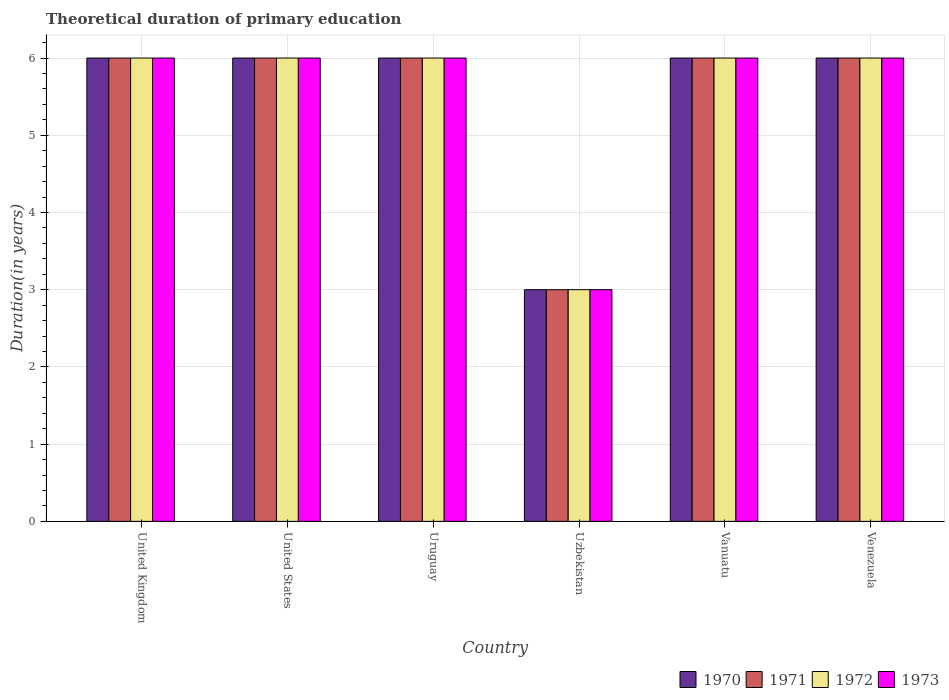Are the number of bars per tick equal to the number of legend labels?
Ensure brevity in your answer.  Yes. Are the number of bars on each tick of the X-axis equal?
Make the answer very short. Yes. How many bars are there on the 3rd tick from the right?
Your answer should be compact. 4. What is the label of the 2nd group of bars from the left?
Your answer should be compact. United States. What is the total theoretical duration of primary education in 1973 in Uzbekistan?
Offer a terse response. 3. Across all countries, what is the minimum total theoretical duration of primary education in 1970?
Give a very brief answer. 3. In which country was the total theoretical duration of primary education in 1970 maximum?
Your answer should be compact. United Kingdom. In which country was the total theoretical duration of primary education in 1972 minimum?
Ensure brevity in your answer.  Uzbekistan. What is the difference between the total theoretical duration of primary education in 1973 in United States and that in Vanuatu?
Provide a succinct answer. 0. In how many countries, is the total theoretical duration of primary education in 1970 greater than 5.4 years?
Ensure brevity in your answer.  5. Is the total theoretical duration of primary education in 1971 in Uruguay less than that in Uzbekistan?
Provide a succinct answer. No. Is it the case that in every country, the sum of the total theoretical duration of primary education in 1972 and total theoretical duration of primary education in 1971 is greater than the total theoretical duration of primary education in 1970?
Keep it short and to the point. Yes. How many countries are there in the graph?
Your answer should be very brief. 6. What is the difference between two consecutive major ticks on the Y-axis?
Your answer should be very brief. 1. Does the graph contain any zero values?
Ensure brevity in your answer.  No. Does the graph contain grids?
Provide a short and direct response. Yes. Where does the legend appear in the graph?
Offer a terse response. Bottom right. What is the title of the graph?
Provide a short and direct response. Theoretical duration of primary education. What is the label or title of the X-axis?
Your answer should be compact. Country. What is the label or title of the Y-axis?
Your answer should be very brief. Duration(in years). What is the Duration(in years) in 1971 in United Kingdom?
Provide a short and direct response. 6. What is the Duration(in years) of 1972 in United Kingdom?
Provide a short and direct response. 6. What is the Duration(in years) of 1973 in United Kingdom?
Keep it short and to the point. 6. What is the Duration(in years) in 1971 in United States?
Your answer should be very brief. 6. What is the Duration(in years) of 1972 in United States?
Keep it short and to the point. 6. What is the Duration(in years) in 1973 in United States?
Provide a succinct answer. 6. What is the Duration(in years) of 1970 in Uruguay?
Make the answer very short. 6. What is the Duration(in years) in 1972 in Uruguay?
Make the answer very short. 6. What is the Duration(in years) of 1973 in Uruguay?
Make the answer very short. 6. What is the Duration(in years) of 1972 in Uzbekistan?
Your answer should be very brief. 3. What is the Duration(in years) in 1973 in Uzbekistan?
Offer a terse response. 3. What is the Duration(in years) of 1973 in Vanuatu?
Give a very brief answer. 6. What is the Duration(in years) of 1971 in Venezuela?
Provide a short and direct response. 6. What is the Duration(in years) in 1972 in Venezuela?
Keep it short and to the point. 6. Across all countries, what is the maximum Duration(in years) of 1971?
Your answer should be compact. 6. Across all countries, what is the maximum Duration(in years) in 1972?
Your answer should be very brief. 6. Across all countries, what is the maximum Duration(in years) of 1973?
Provide a succinct answer. 6. Across all countries, what is the minimum Duration(in years) in 1970?
Make the answer very short. 3. Across all countries, what is the minimum Duration(in years) in 1972?
Make the answer very short. 3. What is the total Duration(in years) in 1971 in the graph?
Provide a short and direct response. 33. What is the total Duration(in years) in 1973 in the graph?
Provide a succinct answer. 33. What is the difference between the Duration(in years) in 1970 in United Kingdom and that in Uruguay?
Provide a short and direct response. 0. What is the difference between the Duration(in years) of 1972 in United Kingdom and that in Uruguay?
Ensure brevity in your answer.  0. What is the difference between the Duration(in years) of 1973 in United Kingdom and that in Uruguay?
Your answer should be very brief. 0. What is the difference between the Duration(in years) of 1970 in United Kingdom and that in Uzbekistan?
Make the answer very short. 3. What is the difference between the Duration(in years) of 1971 in United Kingdom and that in Uzbekistan?
Make the answer very short. 3. What is the difference between the Duration(in years) in 1972 in United Kingdom and that in Uzbekistan?
Keep it short and to the point. 3. What is the difference between the Duration(in years) of 1973 in United Kingdom and that in Uzbekistan?
Give a very brief answer. 3. What is the difference between the Duration(in years) of 1970 in United Kingdom and that in Vanuatu?
Your answer should be compact. 0. What is the difference between the Duration(in years) in 1972 in United Kingdom and that in Vanuatu?
Provide a short and direct response. 0. What is the difference between the Duration(in years) in 1973 in United Kingdom and that in Vanuatu?
Ensure brevity in your answer.  0. What is the difference between the Duration(in years) in 1970 in United Kingdom and that in Venezuela?
Your answer should be compact. 0. What is the difference between the Duration(in years) in 1971 in United Kingdom and that in Venezuela?
Give a very brief answer. 0. What is the difference between the Duration(in years) in 1972 in United Kingdom and that in Venezuela?
Your response must be concise. 0. What is the difference between the Duration(in years) in 1973 in United Kingdom and that in Venezuela?
Your answer should be compact. 0. What is the difference between the Duration(in years) of 1971 in United States and that in Uruguay?
Your response must be concise. 0. What is the difference between the Duration(in years) of 1972 in United States and that in Uzbekistan?
Offer a terse response. 3. What is the difference between the Duration(in years) of 1972 in United States and that in Vanuatu?
Your response must be concise. 0. What is the difference between the Duration(in years) in 1970 in United States and that in Venezuela?
Provide a succinct answer. 0. What is the difference between the Duration(in years) of 1970 in Uruguay and that in Uzbekistan?
Provide a succinct answer. 3. What is the difference between the Duration(in years) in 1972 in Uruguay and that in Uzbekistan?
Your answer should be compact. 3. What is the difference between the Duration(in years) in 1971 in Uruguay and that in Vanuatu?
Offer a very short reply. 0. What is the difference between the Duration(in years) of 1970 in Uzbekistan and that in Vanuatu?
Your answer should be very brief. -3. What is the difference between the Duration(in years) of 1973 in Uzbekistan and that in Vanuatu?
Offer a terse response. -3. What is the difference between the Duration(in years) in 1970 in Uzbekistan and that in Venezuela?
Give a very brief answer. -3. What is the difference between the Duration(in years) in 1971 in Uzbekistan and that in Venezuela?
Give a very brief answer. -3. What is the difference between the Duration(in years) of 1972 in Uzbekistan and that in Venezuela?
Keep it short and to the point. -3. What is the difference between the Duration(in years) in 1970 in Vanuatu and that in Venezuela?
Offer a terse response. 0. What is the difference between the Duration(in years) of 1971 in Vanuatu and that in Venezuela?
Your answer should be very brief. 0. What is the difference between the Duration(in years) of 1970 in United Kingdom and the Duration(in years) of 1971 in United States?
Provide a short and direct response. 0. What is the difference between the Duration(in years) in 1970 in United Kingdom and the Duration(in years) in 1973 in United States?
Offer a very short reply. 0. What is the difference between the Duration(in years) in 1971 in United Kingdom and the Duration(in years) in 1973 in United States?
Your answer should be compact. 0. What is the difference between the Duration(in years) of 1970 in United Kingdom and the Duration(in years) of 1971 in Uruguay?
Offer a terse response. 0. What is the difference between the Duration(in years) in 1971 in United Kingdom and the Duration(in years) in 1973 in Uruguay?
Give a very brief answer. 0. What is the difference between the Duration(in years) in 1970 in United Kingdom and the Duration(in years) in 1971 in Uzbekistan?
Provide a short and direct response. 3. What is the difference between the Duration(in years) of 1971 in United Kingdom and the Duration(in years) of 1972 in Uzbekistan?
Keep it short and to the point. 3. What is the difference between the Duration(in years) of 1970 in United Kingdom and the Duration(in years) of 1972 in Venezuela?
Offer a terse response. 0. What is the difference between the Duration(in years) in 1970 in United Kingdom and the Duration(in years) in 1973 in Venezuela?
Your answer should be very brief. 0. What is the difference between the Duration(in years) of 1971 in United Kingdom and the Duration(in years) of 1972 in Venezuela?
Offer a terse response. 0. What is the difference between the Duration(in years) in 1971 in United Kingdom and the Duration(in years) in 1973 in Venezuela?
Give a very brief answer. 0. What is the difference between the Duration(in years) of 1970 in United States and the Duration(in years) of 1971 in Uruguay?
Your answer should be compact. 0. What is the difference between the Duration(in years) in 1971 in United States and the Duration(in years) in 1973 in Uruguay?
Offer a terse response. 0. What is the difference between the Duration(in years) of 1972 in United States and the Duration(in years) of 1973 in Uruguay?
Provide a succinct answer. 0. What is the difference between the Duration(in years) in 1970 in United States and the Duration(in years) in 1973 in Uzbekistan?
Offer a terse response. 3. What is the difference between the Duration(in years) in 1971 in United States and the Duration(in years) in 1973 in Uzbekistan?
Your answer should be very brief. 3. What is the difference between the Duration(in years) of 1972 in United States and the Duration(in years) of 1973 in Uzbekistan?
Offer a terse response. 3. What is the difference between the Duration(in years) in 1970 in United States and the Duration(in years) in 1971 in Vanuatu?
Your response must be concise. 0. What is the difference between the Duration(in years) in 1970 in United States and the Duration(in years) in 1973 in Vanuatu?
Make the answer very short. 0. What is the difference between the Duration(in years) in 1971 in United States and the Duration(in years) in 1972 in Vanuatu?
Your answer should be compact. 0. What is the difference between the Duration(in years) of 1972 in United States and the Duration(in years) of 1973 in Vanuatu?
Offer a very short reply. 0. What is the difference between the Duration(in years) of 1970 in United States and the Duration(in years) of 1972 in Venezuela?
Keep it short and to the point. 0. What is the difference between the Duration(in years) in 1970 in United States and the Duration(in years) in 1973 in Venezuela?
Your response must be concise. 0. What is the difference between the Duration(in years) of 1971 in United States and the Duration(in years) of 1972 in Venezuela?
Provide a short and direct response. 0. What is the difference between the Duration(in years) of 1971 in United States and the Duration(in years) of 1973 in Venezuela?
Keep it short and to the point. 0. What is the difference between the Duration(in years) in 1972 in United States and the Duration(in years) in 1973 in Venezuela?
Ensure brevity in your answer.  0. What is the difference between the Duration(in years) in 1970 in Uruguay and the Duration(in years) in 1971 in Uzbekistan?
Offer a terse response. 3. What is the difference between the Duration(in years) of 1970 in Uruguay and the Duration(in years) of 1972 in Uzbekistan?
Provide a succinct answer. 3. What is the difference between the Duration(in years) of 1970 in Uruguay and the Duration(in years) of 1973 in Uzbekistan?
Provide a succinct answer. 3. What is the difference between the Duration(in years) of 1971 in Uruguay and the Duration(in years) of 1973 in Uzbekistan?
Ensure brevity in your answer.  3. What is the difference between the Duration(in years) of 1972 in Uruguay and the Duration(in years) of 1973 in Uzbekistan?
Make the answer very short. 3. What is the difference between the Duration(in years) of 1972 in Uruguay and the Duration(in years) of 1973 in Vanuatu?
Keep it short and to the point. 0. What is the difference between the Duration(in years) in 1971 in Uruguay and the Duration(in years) in 1972 in Venezuela?
Give a very brief answer. 0. What is the difference between the Duration(in years) in 1972 in Uruguay and the Duration(in years) in 1973 in Venezuela?
Provide a short and direct response. 0. What is the difference between the Duration(in years) in 1970 in Uzbekistan and the Duration(in years) in 1971 in Vanuatu?
Make the answer very short. -3. What is the difference between the Duration(in years) of 1972 in Uzbekistan and the Duration(in years) of 1973 in Vanuatu?
Ensure brevity in your answer.  -3. What is the difference between the Duration(in years) in 1970 in Uzbekistan and the Duration(in years) in 1973 in Venezuela?
Provide a short and direct response. -3. What is the difference between the Duration(in years) in 1972 in Uzbekistan and the Duration(in years) in 1973 in Venezuela?
Your answer should be compact. -3. What is the difference between the Duration(in years) in 1970 in Vanuatu and the Duration(in years) in 1972 in Venezuela?
Offer a terse response. 0. What is the difference between the Duration(in years) in 1971 in Vanuatu and the Duration(in years) in 1973 in Venezuela?
Ensure brevity in your answer.  0. What is the difference between the Duration(in years) of 1972 in Vanuatu and the Duration(in years) of 1973 in Venezuela?
Provide a succinct answer. 0. What is the average Duration(in years) in 1972 per country?
Your answer should be very brief. 5.5. What is the difference between the Duration(in years) in 1970 and Duration(in years) in 1973 in United Kingdom?
Your response must be concise. 0. What is the difference between the Duration(in years) of 1970 and Duration(in years) of 1971 in United States?
Provide a short and direct response. 0. What is the difference between the Duration(in years) in 1971 and Duration(in years) in 1973 in United States?
Provide a succinct answer. 0. What is the difference between the Duration(in years) of 1970 and Duration(in years) of 1973 in Uruguay?
Offer a very short reply. 0. What is the difference between the Duration(in years) in 1970 and Duration(in years) in 1971 in Uzbekistan?
Give a very brief answer. 0. What is the difference between the Duration(in years) of 1970 and Duration(in years) of 1973 in Uzbekistan?
Your answer should be compact. 0. What is the difference between the Duration(in years) in 1972 and Duration(in years) in 1973 in Uzbekistan?
Your answer should be compact. 0. What is the difference between the Duration(in years) of 1970 and Duration(in years) of 1972 in Vanuatu?
Your response must be concise. 0. What is the difference between the Duration(in years) in 1971 and Duration(in years) in 1973 in Vanuatu?
Provide a succinct answer. 0. What is the difference between the Duration(in years) in 1972 and Duration(in years) in 1973 in Vanuatu?
Offer a very short reply. 0. What is the difference between the Duration(in years) of 1970 and Duration(in years) of 1971 in Venezuela?
Provide a succinct answer. 0. What is the difference between the Duration(in years) of 1970 and Duration(in years) of 1972 in Venezuela?
Your answer should be very brief. 0. What is the difference between the Duration(in years) in 1971 and Duration(in years) in 1973 in Venezuela?
Offer a very short reply. 0. What is the difference between the Duration(in years) in 1972 and Duration(in years) in 1973 in Venezuela?
Offer a very short reply. 0. What is the ratio of the Duration(in years) in 1973 in United Kingdom to that in United States?
Make the answer very short. 1. What is the ratio of the Duration(in years) in 1972 in United Kingdom to that in Uruguay?
Give a very brief answer. 1. What is the ratio of the Duration(in years) in 1973 in United Kingdom to that in Uruguay?
Ensure brevity in your answer.  1. What is the ratio of the Duration(in years) of 1971 in United Kingdom to that in Uzbekistan?
Provide a short and direct response. 2. What is the ratio of the Duration(in years) in 1972 in United Kingdom to that in Uzbekistan?
Provide a short and direct response. 2. What is the ratio of the Duration(in years) in 1973 in United Kingdom to that in Uzbekistan?
Offer a terse response. 2. What is the ratio of the Duration(in years) in 1971 in United Kingdom to that in Vanuatu?
Your answer should be compact. 1. What is the ratio of the Duration(in years) of 1973 in United Kingdom to that in Vanuatu?
Ensure brevity in your answer.  1. What is the ratio of the Duration(in years) of 1973 in United Kingdom to that in Venezuela?
Your answer should be compact. 1. What is the ratio of the Duration(in years) in 1971 in United States to that in Uruguay?
Provide a short and direct response. 1. What is the ratio of the Duration(in years) of 1972 in United States to that in Uruguay?
Provide a succinct answer. 1. What is the ratio of the Duration(in years) in 1973 in United States to that in Uruguay?
Make the answer very short. 1. What is the ratio of the Duration(in years) of 1970 in United States to that in Uzbekistan?
Provide a succinct answer. 2. What is the ratio of the Duration(in years) in 1971 in United States to that in Uzbekistan?
Provide a short and direct response. 2. What is the ratio of the Duration(in years) of 1973 in United States to that in Uzbekistan?
Provide a short and direct response. 2. What is the ratio of the Duration(in years) of 1970 in United States to that in Vanuatu?
Provide a short and direct response. 1. What is the ratio of the Duration(in years) in 1973 in United States to that in Vanuatu?
Provide a short and direct response. 1. What is the ratio of the Duration(in years) of 1970 in United States to that in Venezuela?
Your answer should be very brief. 1. What is the ratio of the Duration(in years) in 1973 in United States to that in Venezuela?
Give a very brief answer. 1. What is the ratio of the Duration(in years) in 1970 in Uruguay to that in Uzbekistan?
Ensure brevity in your answer.  2. What is the ratio of the Duration(in years) of 1971 in Uruguay to that in Uzbekistan?
Offer a very short reply. 2. What is the ratio of the Duration(in years) of 1970 in Uruguay to that in Vanuatu?
Provide a succinct answer. 1. What is the ratio of the Duration(in years) of 1973 in Uruguay to that in Vanuatu?
Your response must be concise. 1. What is the ratio of the Duration(in years) in 1971 in Uzbekistan to that in Vanuatu?
Provide a short and direct response. 0.5. What is the ratio of the Duration(in years) of 1972 in Uzbekistan to that in Vanuatu?
Ensure brevity in your answer.  0.5. What is the ratio of the Duration(in years) of 1973 in Uzbekistan to that in Vanuatu?
Offer a terse response. 0.5. What is the ratio of the Duration(in years) in 1971 in Uzbekistan to that in Venezuela?
Make the answer very short. 0.5. What is the ratio of the Duration(in years) of 1973 in Uzbekistan to that in Venezuela?
Offer a terse response. 0.5. What is the ratio of the Duration(in years) in 1970 in Vanuatu to that in Venezuela?
Your response must be concise. 1. What is the ratio of the Duration(in years) of 1971 in Vanuatu to that in Venezuela?
Make the answer very short. 1. What is the ratio of the Duration(in years) in 1972 in Vanuatu to that in Venezuela?
Make the answer very short. 1. What is the difference between the highest and the second highest Duration(in years) in 1970?
Your answer should be compact. 0. What is the difference between the highest and the second highest Duration(in years) of 1972?
Your response must be concise. 0. What is the difference between the highest and the lowest Duration(in years) in 1972?
Your answer should be very brief. 3. What is the difference between the highest and the lowest Duration(in years) of 1973?
Your response must be concise. 3. 